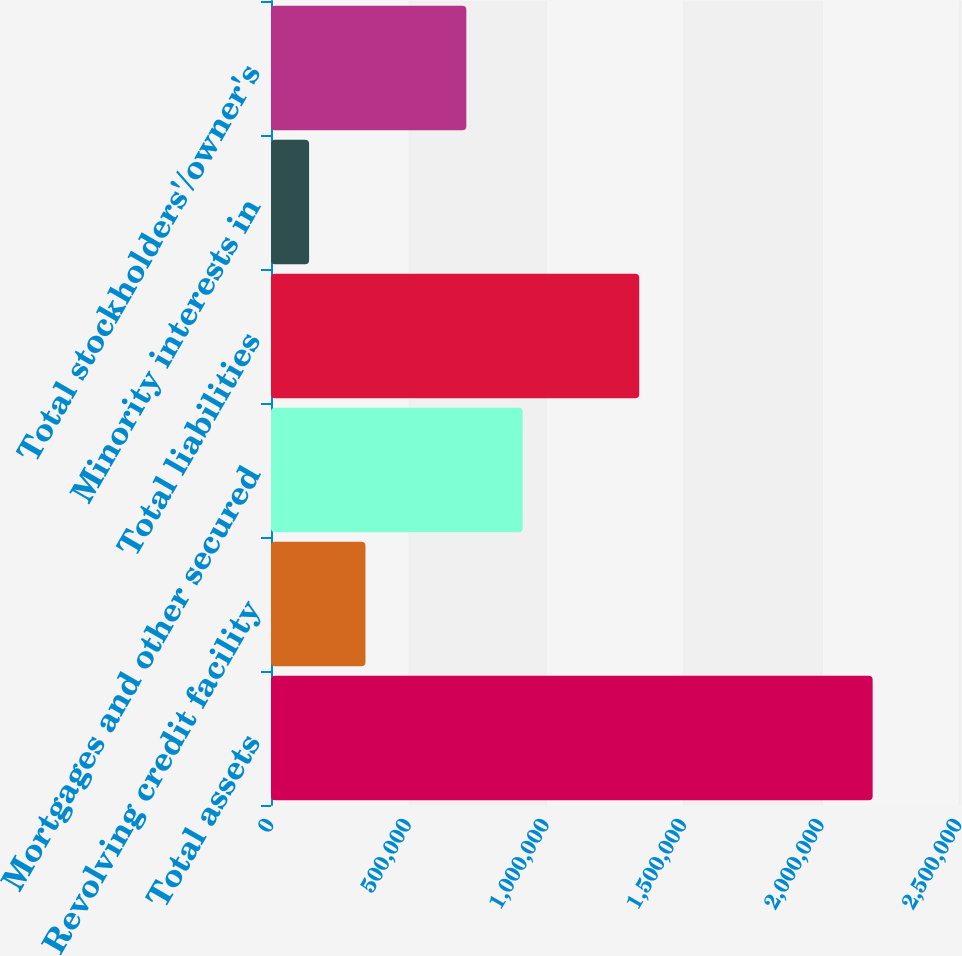Convert chart to OTSL. <chart><loc_0><loc_0><loc_500><loc_500><bar_chart><fcel>Total assets<fcel>Revolving credit facility<fcel>Mortgages and other secured<fcel>Total liabilities<fcel>Minority interests in<fcel>Total stockholders'/owner's<nl><fcel>2.18622e+06<fcel>343196<fcel>914552<fcel>1.33803e+06<fcel>138416<fcel>709772<nl></chart> 